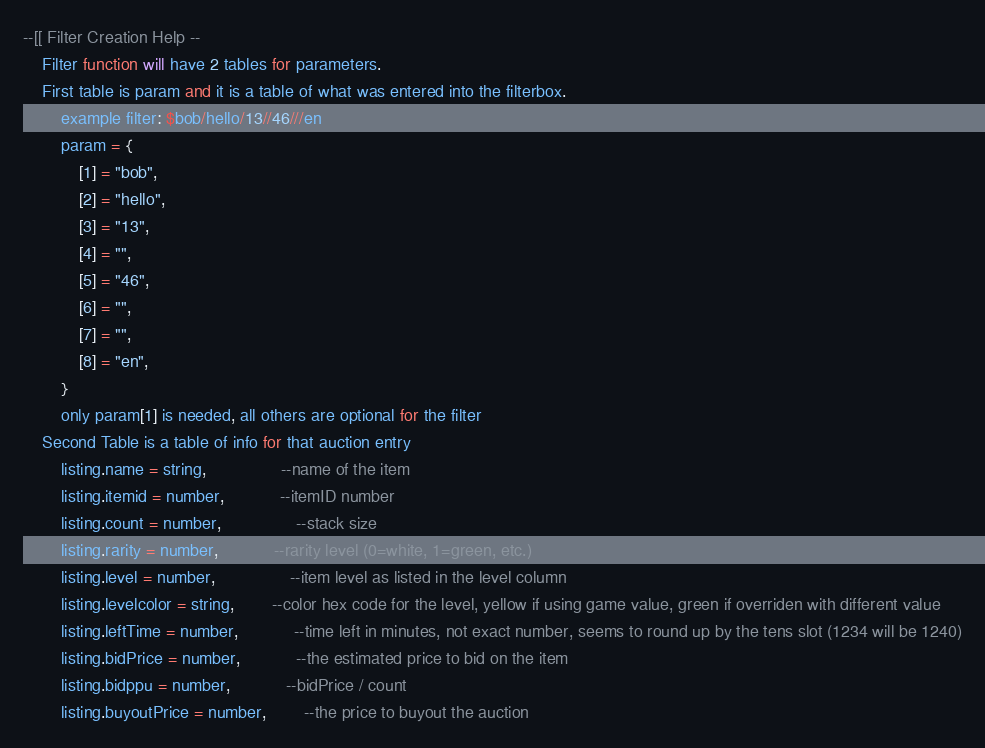Convert code to text. <code><loc_0><loc_0><loc_500><loc_500><_Lua_>--[[ Filter Creation Help --
	Filter function will have 2 tables for parameters.
	First table is param and it is a table of what was entered into the filterbox.
		example filter: $bob/hello/13//46///en
		param = {
			[1] = "bob",
			[2] = "hello",
			[3] = "13",
			[4] = "",
			[5] = "46",
			[6] = "",
			[7] = "",
			[8] = "en",
		}
		only param[1] is needed, all others are optional for the filter
	Second Table is a table of info for that auction entry
		listing.name = string,				--name of the item
		listing.itemid = number,			--itemID number
		listing.count = number,				--stack size
		listing.rarity = number,			--rarity level (0=white, 1=green, etc.)
		listing.level = number,				--item level as listed in the level column
		listing.levelcolor = string,		--color hex code for the level, yellow if using game value, green if overriden with different value
		listing.leftTime = number,			--time left in minutes, not exact number, seems to round up by the tens slot (1234 will be 1240)
		listing.bidPrice = number,			--the estimated price to bid on the item
		listing.bidppu = number,			--bidPrice / count
		listing.buyoutPrice = number,		--the price to buyout the auction</code> 